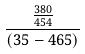<formula> <loc_0><loc_0><loc_500><loc_500>\frac { \frac { 3 8 0 } { 4 5 4 } } { ( 3 5 - 4 6 5 ) }</formula> 